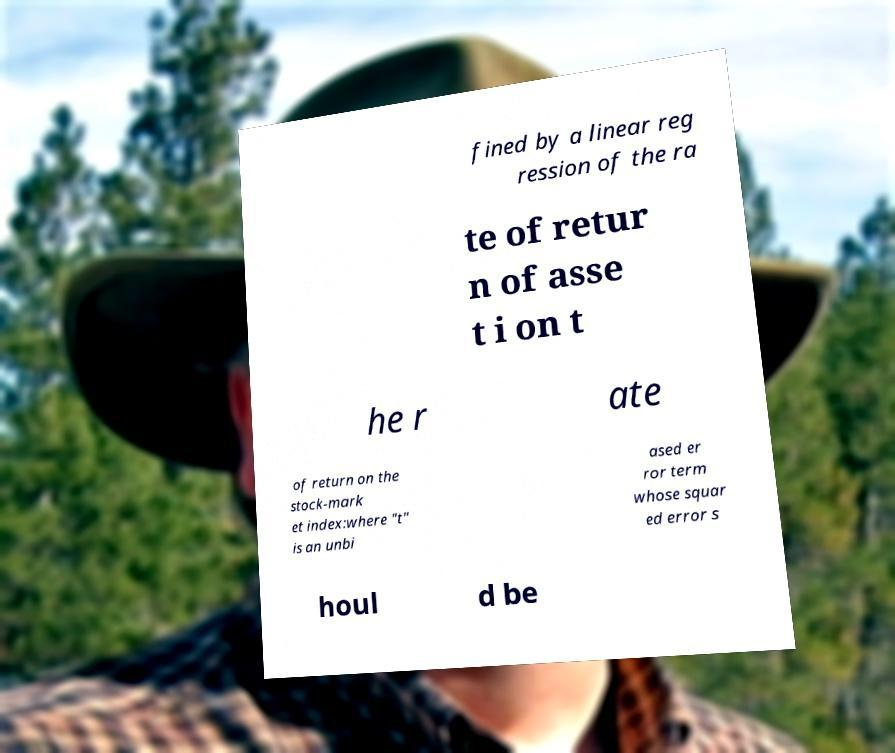Please identify and transcribe the text found in this image. fined by a linear reg ression of the ra te of retur n of asse t i on t he r ate of return on the stock-mark et index:where "t" is an unbi ased er ror term whose squar ed error s houl d be 